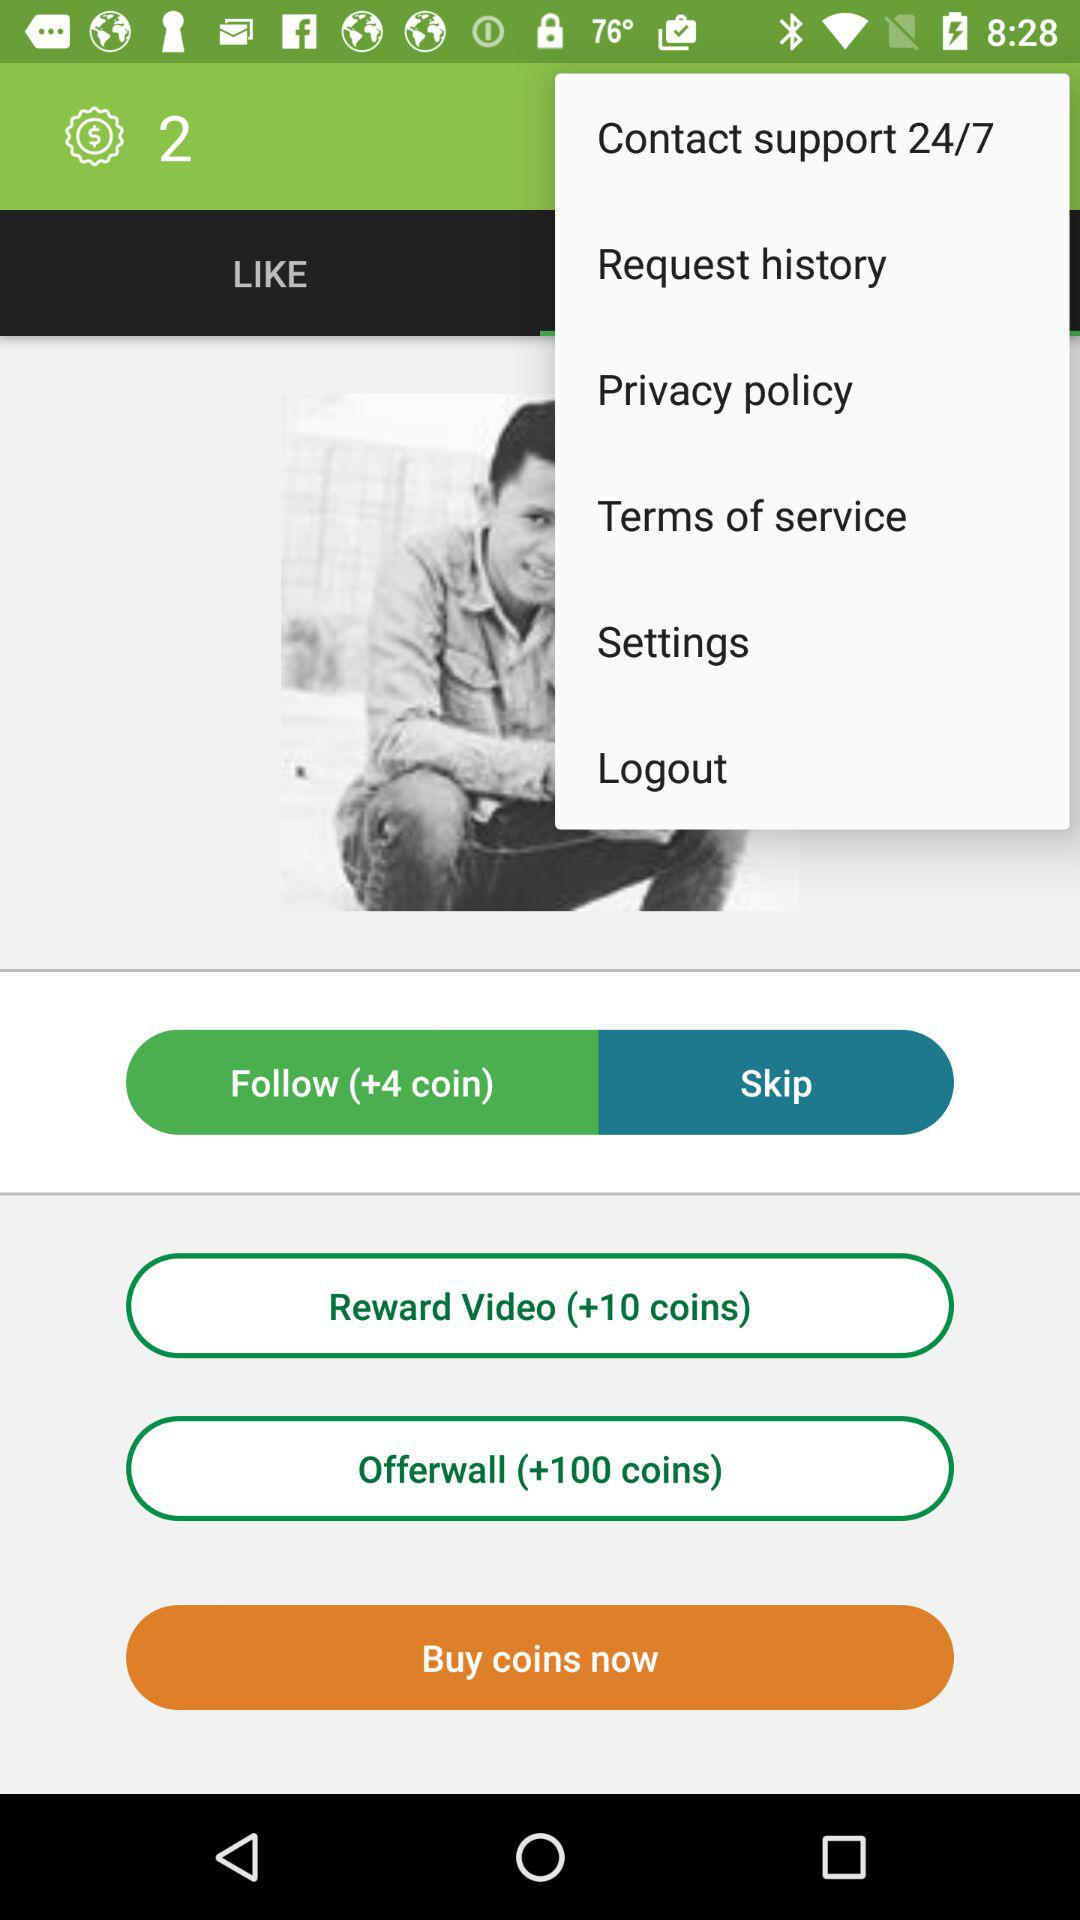How many more coins can I earn by watching a reward video than by clicking on the offerwall?
Answer the question using a single word or phrase. 90 